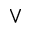Convert formula to latex. <formula><loc_0><loc_0><loc_500><loc_500>\vee</formula> 